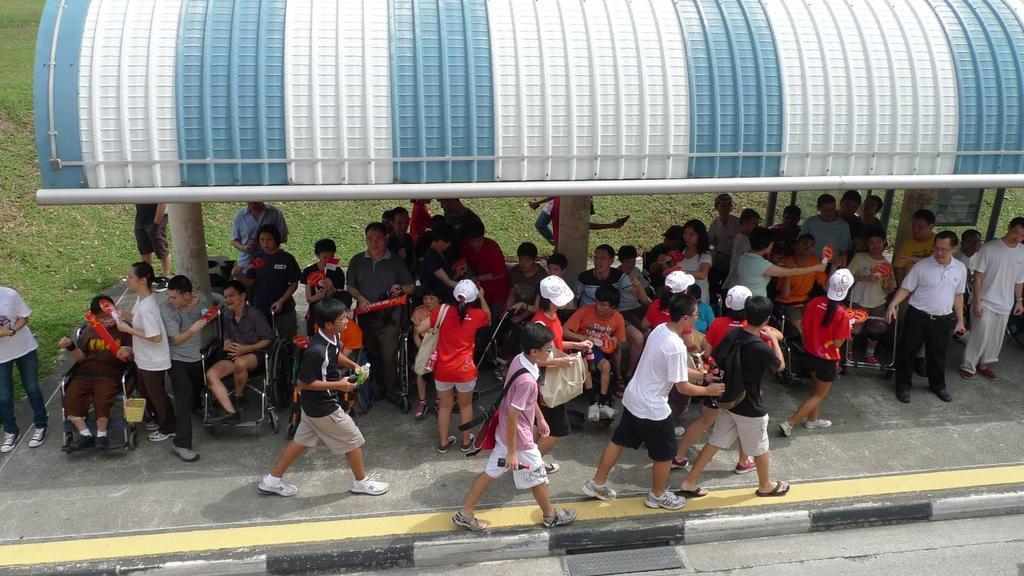In one or two sentences, can you explain what this image depicts? Here in this picture we can see a shed, under which we can see number of people sitting on the wheel chairs and we can see other number of people and children standing and walking over there and some of them are wearing caps on them and some of them are carrying handbags and bags with them and beside them we can see the ground is fully covered with grass over there. 